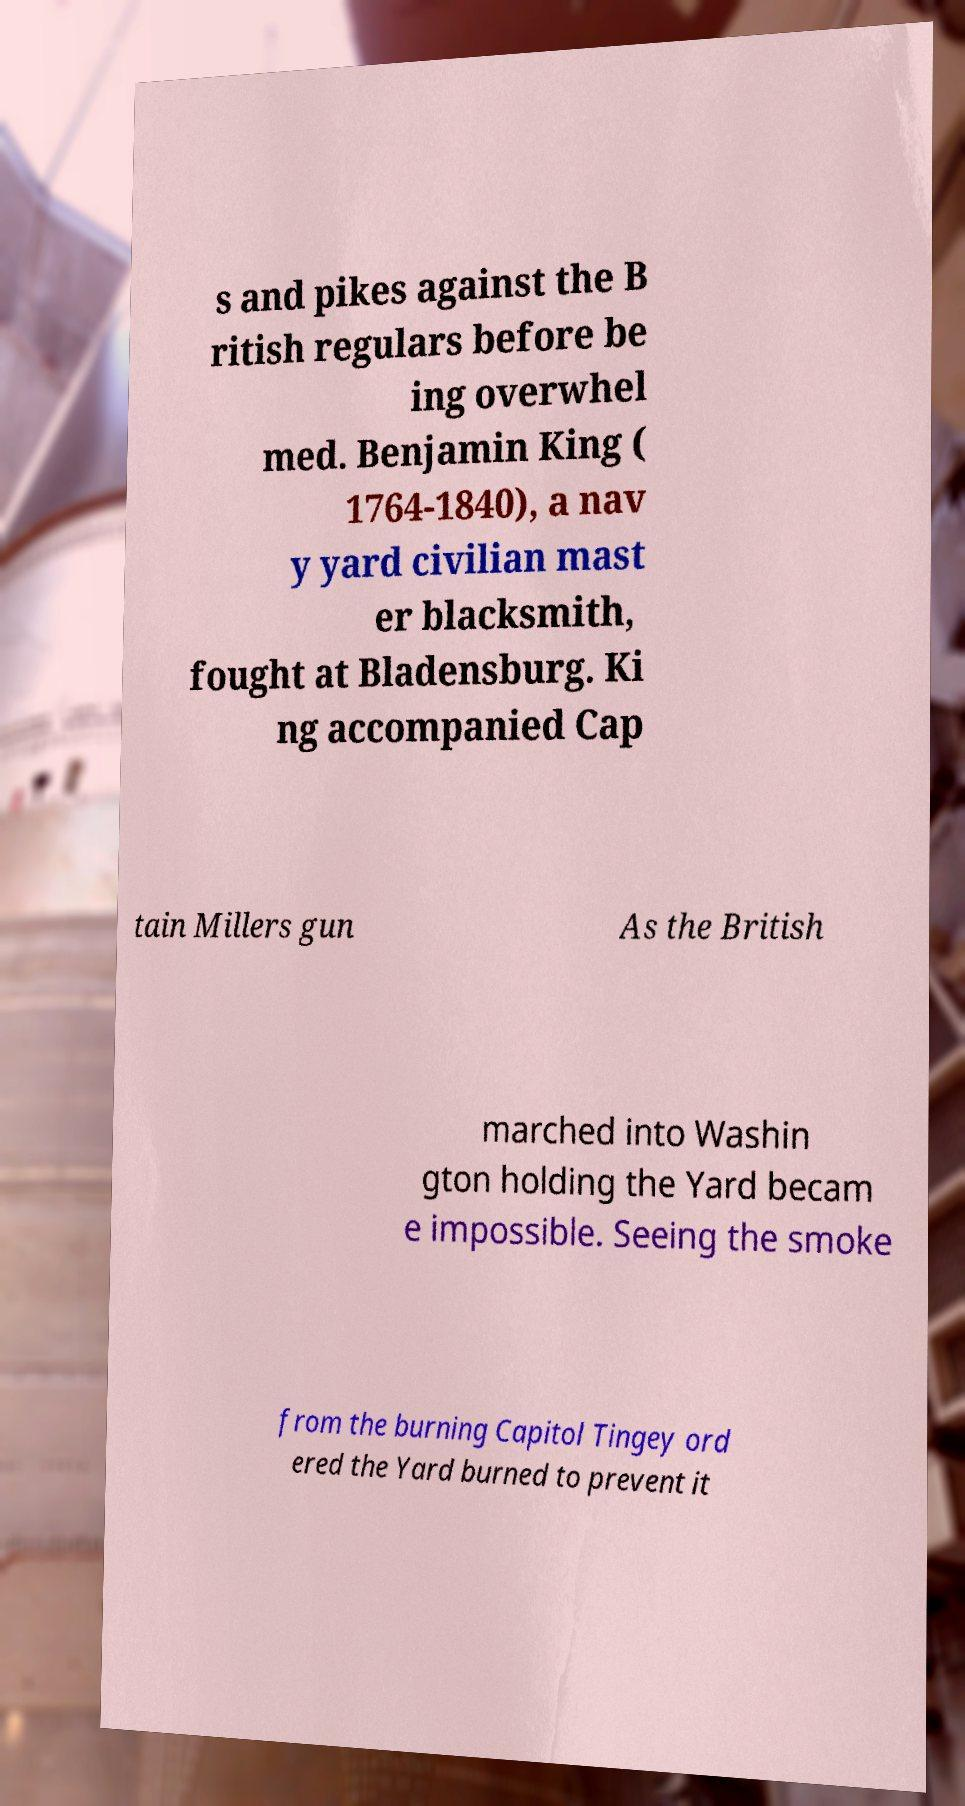Can you accurately transcribe the text from the provided image for me? s and pikes against the B ritish regulars before be ing overwhel med. Benjamin King ( 1764-1840), a nav y yard civilian mast er blacksmith, fought at Bladensburg. Ki ng accompanied Cap tain Millers gun As the British marched into Washin gton holding the Yard becam e impossible. Seeing the smoke from the burning Capitol Tingey ord ered the Yard burned to prevent it 